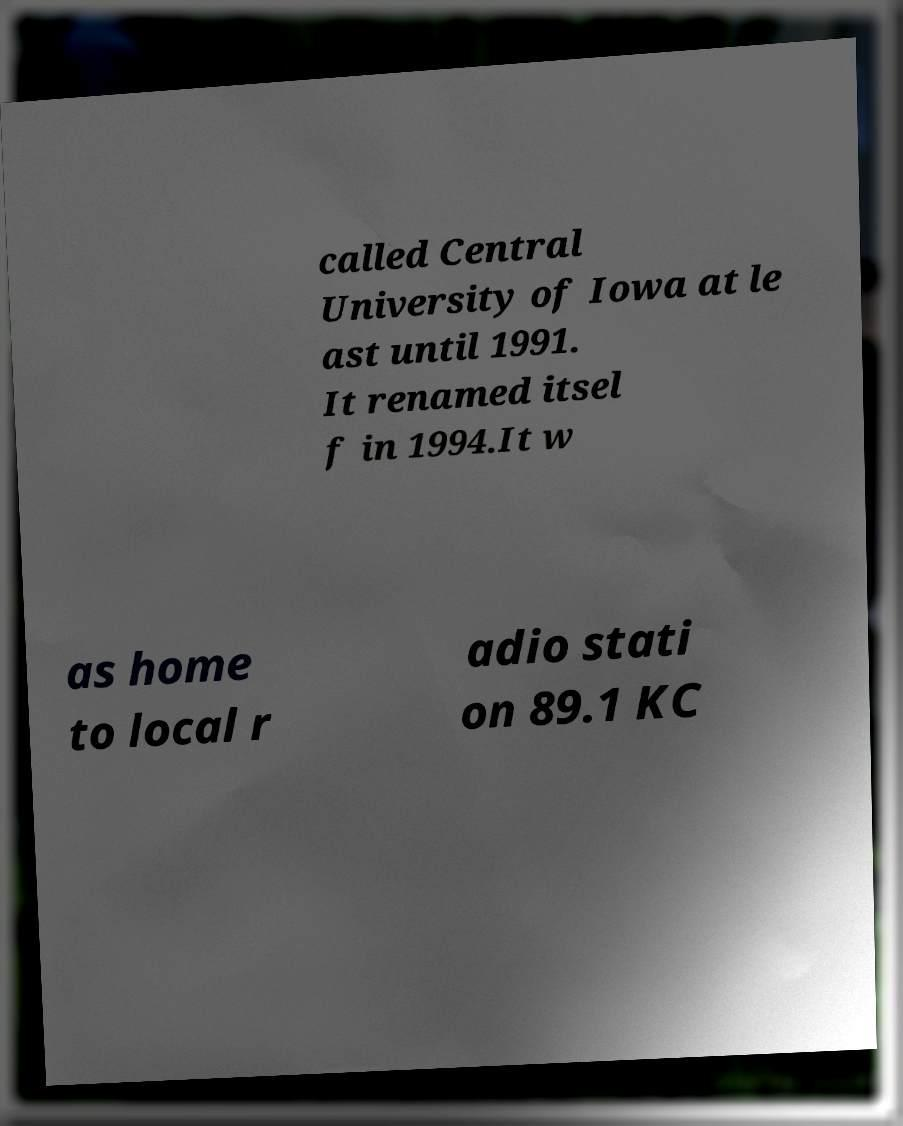I need the written content from this picture converted into text. Can you do that? called Central University of Iowa at le ast until 1991. It renamed itsel f in 1994.It w as home to local r adio stati on 89.1 KC 